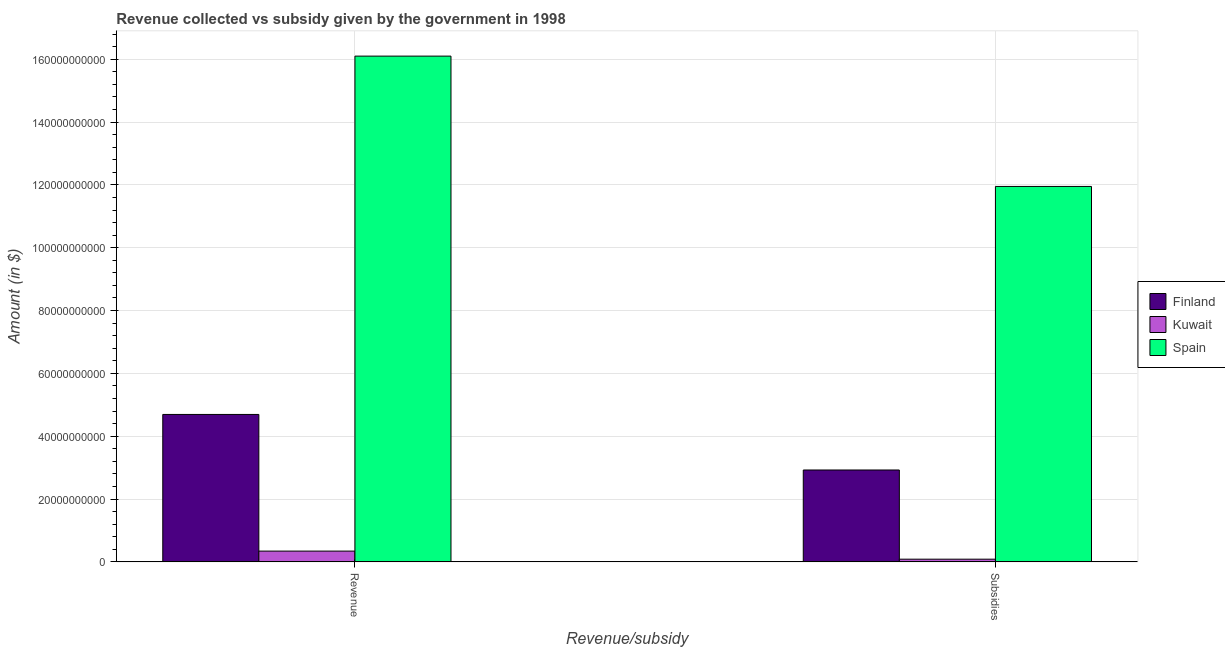How many different coloured bars are there?
Make the answer very short. 3. What is the label of the 1st group of bars from the left?
Give a very brief answer. Revenue. What is the amount of subsidies given in Kuwait?
Your response must be concise. 8.65e+08. Across all countries, what is the maximum amount of revenue collected?
Ensure brevity in your answer.  1.61e+11. Across all countries, what is the minimum amount of revenue collected?
Provide a succinct answer. 3.44e+09. In which country was the amount of subsidies given minimum?
Provide a succinct answer. Kuwait. What is the total amount of subsidies given in the graph?
Provide a short and direct response. 1.50e+11. What is the difference between the amount of revenue collected in Finland and that in Spain?
Your answer should be compact. -1.14e+11. What is the difference between the amount of revenue collected in Kuwait and the amount of subsidies given in Spain?
Ensure brevity in your answer.  -1.16e+11. What is the average amount of revenue collected per country?
Give a very brief answer. 7.05e+1. What is the difference between the amount of subsidies given and amount of revenue collected in Spain?
Offer a terse response. -4.15e+1. In how many countries, is the amount of subsidies given greater than 4000000000 $?
Your answer should be very brief. 2. What is the ratio of the amount of revenue collected in Kuwait to that in Finland?
Your answer should be very brief. 0.07. Is the amount of subsidies given in Kuwait less than that in Finland?
Make the answer very short. Yes. In how many countries, is the amount of subsidies given greater than the average amount of subsidies given taken over all countries?
Ensure brevity in your answer.  1. What does the 2nd bar from the right in Subsidies represents?
Provide a short and direct response. Kuwait. Does the graph contain grids?
Keep it short and to the point. Yes. What is the title of the graph?
Your response must be concise. Revenue collected vs subsidy given by the government in 1998. Does "Nigeria" appear as one of the legend labels in the graph?
Offer a very short reply. No. What is the label or title of the X-axis?
Provide a succinct answer. Revenue/subsidy. What is the label or title of the Y-axis?
Give a very brief answer. Amount (in $). What is the Amount (in $) of Finland in Revenue?
Offer a very short reply. 4.69e+1. What is the Amount (in $) of Kuwait in Revenue?
Your answer should be very brief. 3.44e+09. What is the Amount (in $) of Spain in Revenue?
Your answer should be compact. 1.61e+11. What is the Amount (in $) in Finland in Subsidies?
Give a very brief answer. 2.93e+1. What is the Amount (in $) in Kuwait in Subsidies?
Your answer should be compact. 8.65e+08. What is the Amount (in $) in Spain in Subsidies?
Make the answer very short. 1.20e+11. Across all Revenue/subsidy, what is the maximum Amount (in $) of Finland?
Make the answer very short. 4.69e+1. Across all Revenue/subsidy, what is the maximum Amount (in $) of Kuwait?
Your answer should be compact. 3.44e+09. Across all Revenue/subsidy, what is the maximum Amount (in $) in Spain?
Your answer should be very brief. 1.61e+11. Across all Revenue/subsidy, what is the minimum Amount (in $) in Finland?
Your answer should be very brief. 2.93e+1. Across all Revenue/subsidy, what is the minimum Amount (in $) in Kuwait?
Offer a terse response. 8.65e+08. Across all Revenue/subsidy, what is the minimum Amount (in $) in Spain?
Provide a short and direct response. 1.20e+11. What is the total Amount (in $) of Finland in the graph?
Provide a succinct answer. 7.62e+1. What is the total Amount (in $) of Kuwait in the graph?
Keep it short and to the point. 4.30e+09. What is the total Amount (in $) of Spain in the graph?
Offer a very short reply. 2.80e+11. What is the difference between the Amount (in $) of Finland in Revenue and that in Subsidies?
Your response must be concise. 1.77e+1. What is the difference between the Amount (in $) of Kuwait in Revenue and that in Subsidies?
Give a very brief answer. 2.57e+09. What is the difference between the Amount (in $) of Spain in Revenue and that in Subsidies?
Your response must be concise. 4.15e+1. What is the difference between the Amount (in $) of Finland in Revenue and the Amount (in $) of Kuwait in Subsidies?
Ensure brevity in your answer.  4.61e+1. What is the difference between the Amount (in $) in Finland in Revenue and the Amount (in $) in Spain in Subsidies?
Your answer should be compact. -7.26e+1. What is the difference between the Amount (in $) in Kuwait in Revenue and the Amount (in $) in Spain in Subsidies?
Make the answer very short. -1.16e+11. What is the average Amount (in $) in Finland per Revenue/subsidy?
Provide a short and direct response. 3.81e+1. What is the average Amount (in $) in Kuwait per Revenue/subsidy?
Ensure brevity in your answer.  2.15e+09. What is the average Amount (in $) in Spain per Revenue/subsidy?
Keep it short and to the point. 1.40e+11. What is the difference between the Amount (in $) of Finland and Amount (in $) of Kuwait in Revenue?
Give a very brief answer. 4.35e+1. What is the difference between the Amount (in $) in Finland and Amount (in $) in Spain in Revenue?
Make the answer very short. -1.14e+11. What is the difference between the Amount (in $) of Kuwait and Amount (in $) of Spain in Revenue?
Offer a terse response. -1.58e+11. What is the difference between the Amount (in $) in Finland and Amount (in $) in Kuwait in Subsidies?
Make the answer very short. 2.84e+1. What is the difference between the Amount (in $) in Finland and Amount (in $) in Spain in Subsidies?
Provide a short and direct response. -9.03e+1. What is the difference between the Amount (in $) in Kuwait and Amount (in $) in Spain in Subsidies?
Offer a very short reply. -1.19e+11. What is the ratio of the Amount (in $) of Finland in Revenue to that in Subsidies?
Ensure brevity in your answer.  1.6. What is the ratio of the Amount (in $) in Kuwait in Revenue to that in Subsidies?
Your answer should be compact. 3.97. What is the ratio of the Amount (in $) in Spain in Revenue to that in Subsidies?
Your answer should be compact. 1.35. What is the difference between the highest and the second highest Amount (in $) of Finland?
Give a very brief answer. 1.77e+1. What is the difference between the highest and the second highest Amount (in $) of Kuwait?
Ensure brevity in your answer.  2.57e+09. What is the difference between the highest and the second highest Amount (in $) in Spain?
Ensure brevity in your answer.  4.15e+1. What is the difference between the highest and the lowest Amount (in $) in Finland?
Ensure brevity in your answer.  1.77e+1. What is the difference between the highest and the lowest Amount (in $) in Kuwait?
Your answer should be very brief. 2.57e+09. What is the difference between the highest and the lowest Amount (in $) of Spain?
Provide a succinct answer. 4.15e+1. 